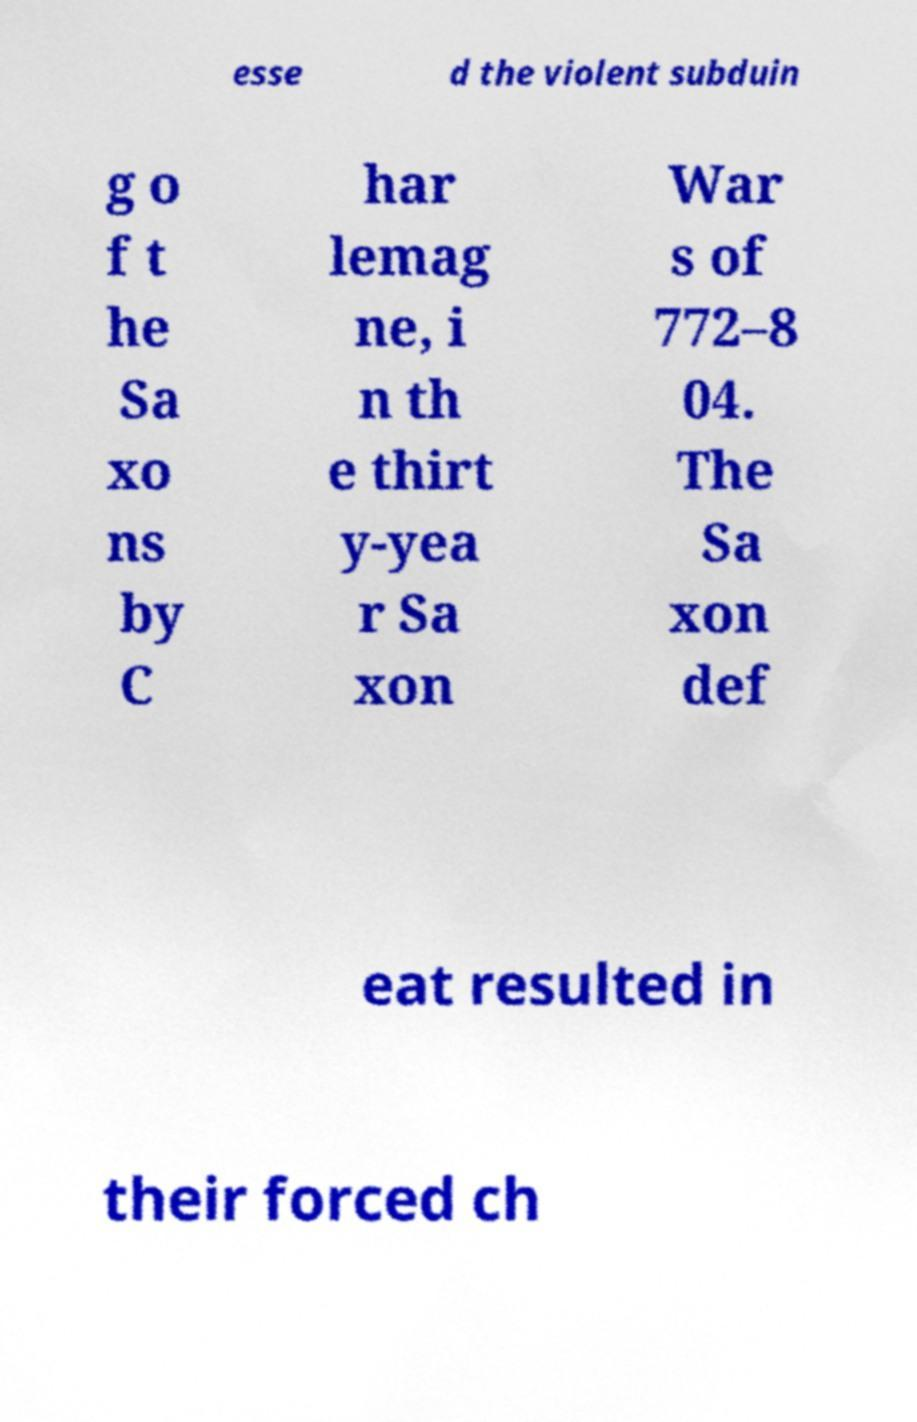Please read and relay the text visible in this image. What does it say? esse d the violent subduin g o f t he Sa xo ns by C har lemag ne, i n th e thirt y-yea r Sa xon War s of 772–8 04. The Sa xon def eat resulted in their forced ch 